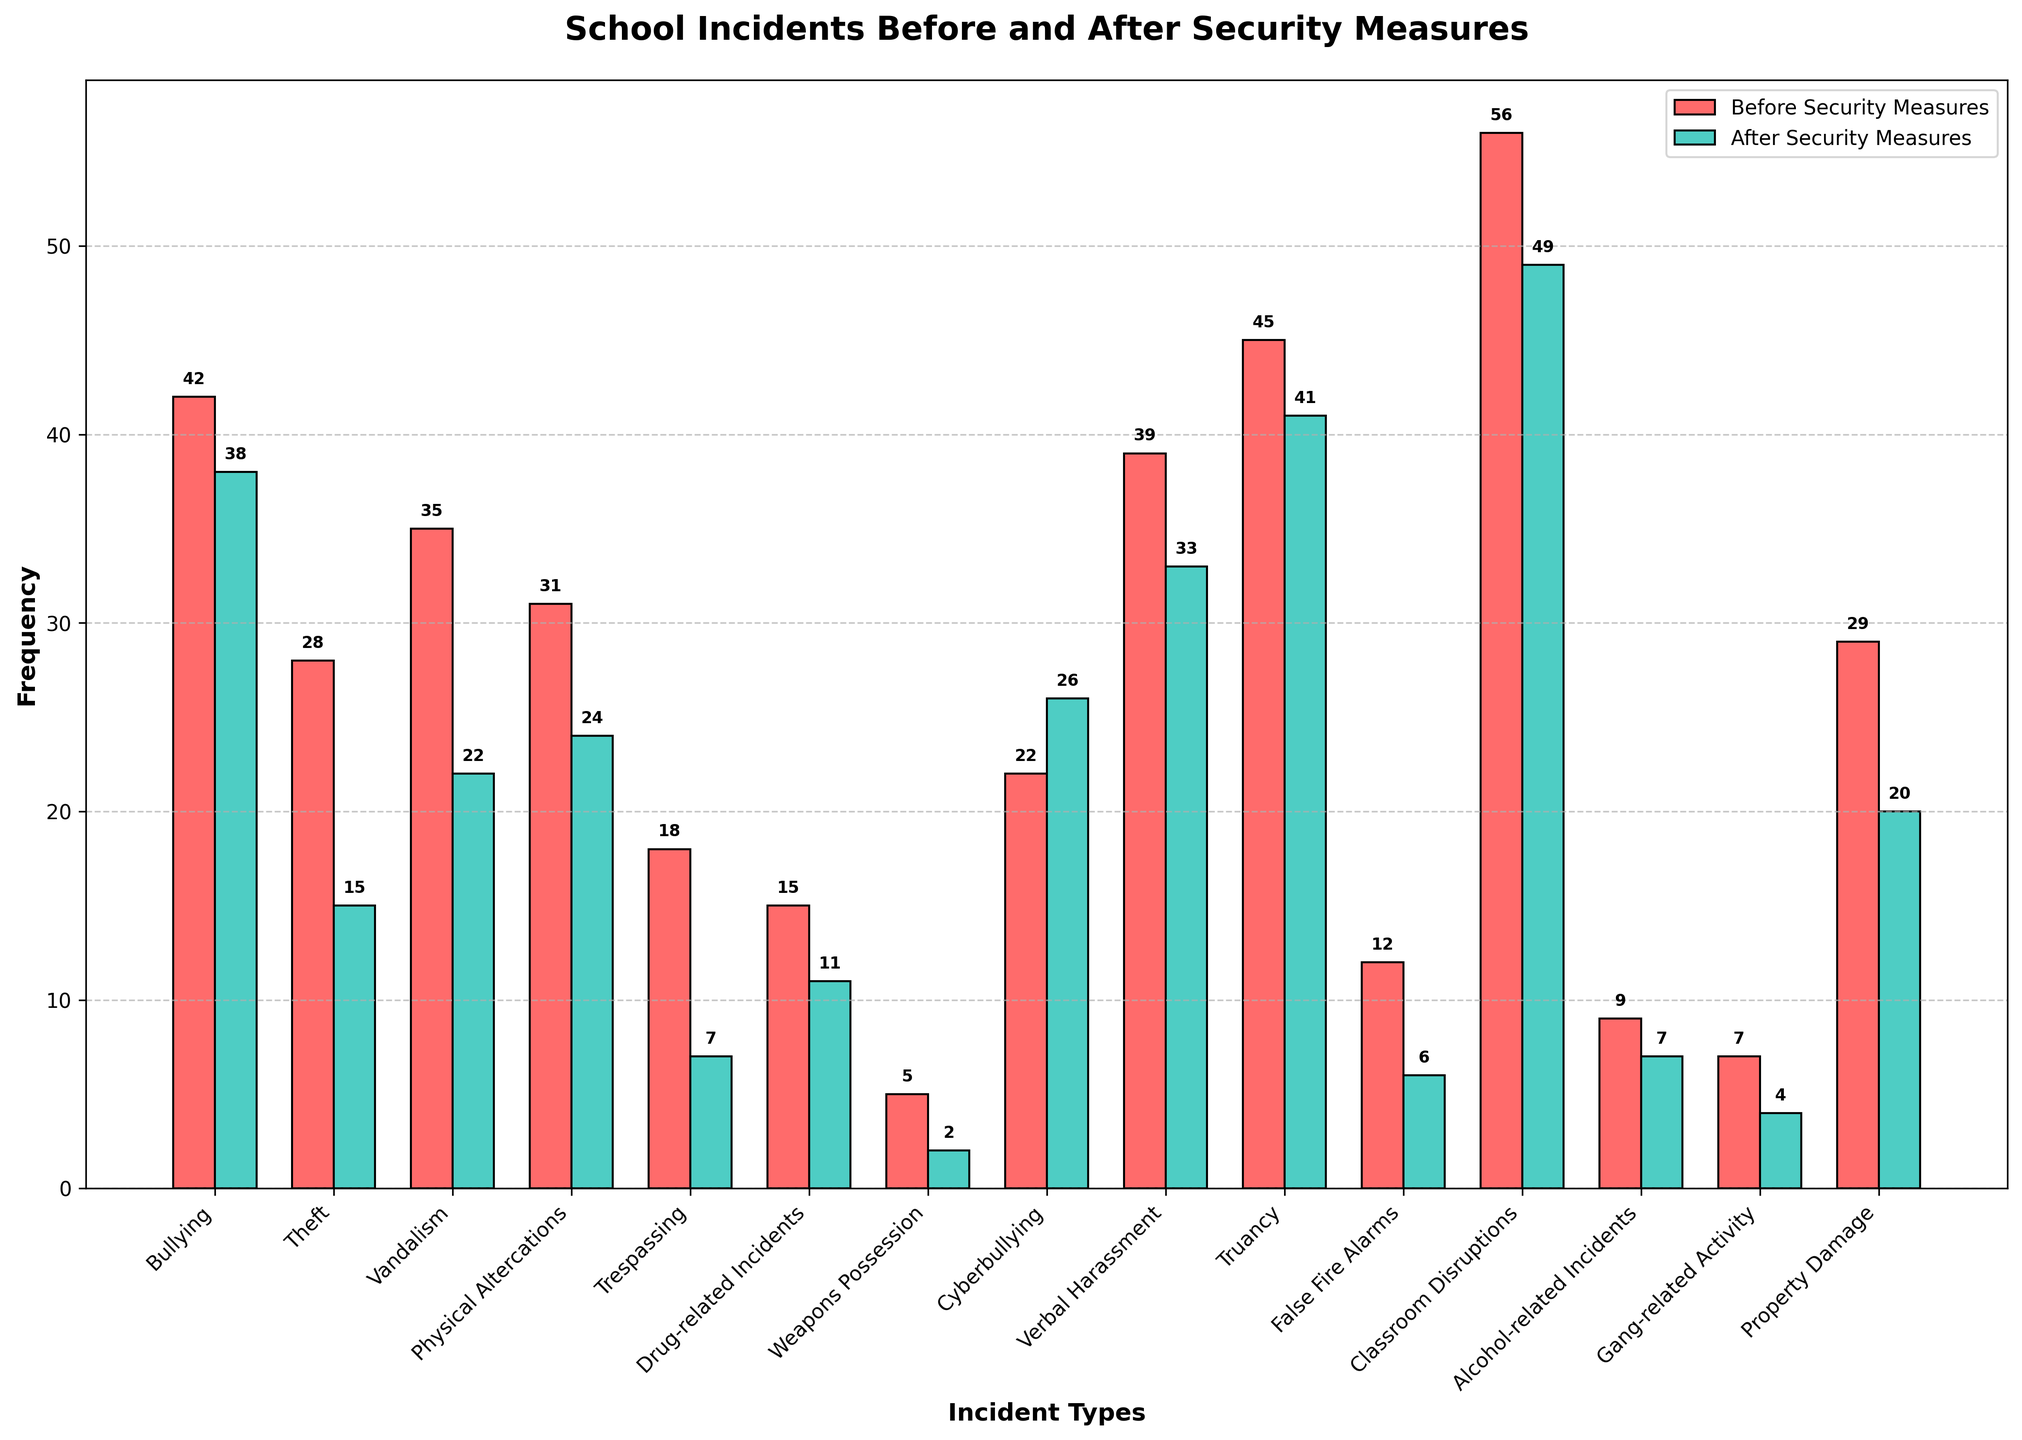Which incident type saw the largest decline in frequency after the implementation of security measures? Identify the difference in frequencies for each incident type before and after security measures and find the largest one. The largest decline is for "Trespassing" which went from 18 to 7.
Answer: Trespassing Which incident type actually increased in frequency after heightened security measures were implemented? Compare the frequencies before and after security measures for each incident type and note any increases. "Cyberbullying" increased from 22 to 26.
Answer: Cyberbullying What is the total frequency of all incidents before and after security measures were put in place? Sum all frequencies for both before and after columns. Before: 42+28+35+31+18+15+5+22+39+45+12+56+9+7+29=393, After: 38+15+22+24+7+11+2+26+33+41+6+49+7+4+20=305.
Answer: Before: 393, After: 305 Which incident shows the smallest change in frequency after the implementation of security measures? Calculate the absolute differences for all incident types and find the smallest one. The smallest change is in "Alcohol-related Incidents" which decreased by 2 (from 9 to 7).
Answer: Alcohol-related Incidents How many incident types decreased in frequency after the security measures were implemented? Count all incident types which have their "After Security Measures" value less than their "Before Security Measures" value.
Answer: 12 Between "Bullying" and "Verbal Harassment", which one saw a greater decrease in frequency after the implementation of security measures? Calculate the decrease for both incidents: "Bullying" from 42 to 38 (decrease of 4), "Verbal Harassment" from 39 to 33 (decrease of 6). "Verbal Harassment" has the greater decrease.
Answer: Verbal Harassment Which incident type had the highest frequency before the implementation of security measures? Identify the incident with the maximum value in the "Before Security Measures" column. "Classroom Disruptions" has the highest frequency at 56.
Answer: Classroom Disruptions What is the average frequency of all incident types after the implementation of security measures? Calculate the average by summing the values in the "After Security Measures" column and dividing by the number of incident types. (305 / 15)
Answer: 20.33 By how much did the frequency of "Vandalism" decrease after implementing security measures? Subtract the frequency of "Vandalism" after security measures from the frequency before security measures: (35 - 22).
Answer: 13 Is the frequency of drug-related incidents before security measures higher, lower, or the same compared to alcohol-related incidents after security measures? Compare the frequency of drug-related incidents before (15) with alcohol-related incidents after (7). 15 is greater than 7.
Answer: Higher 